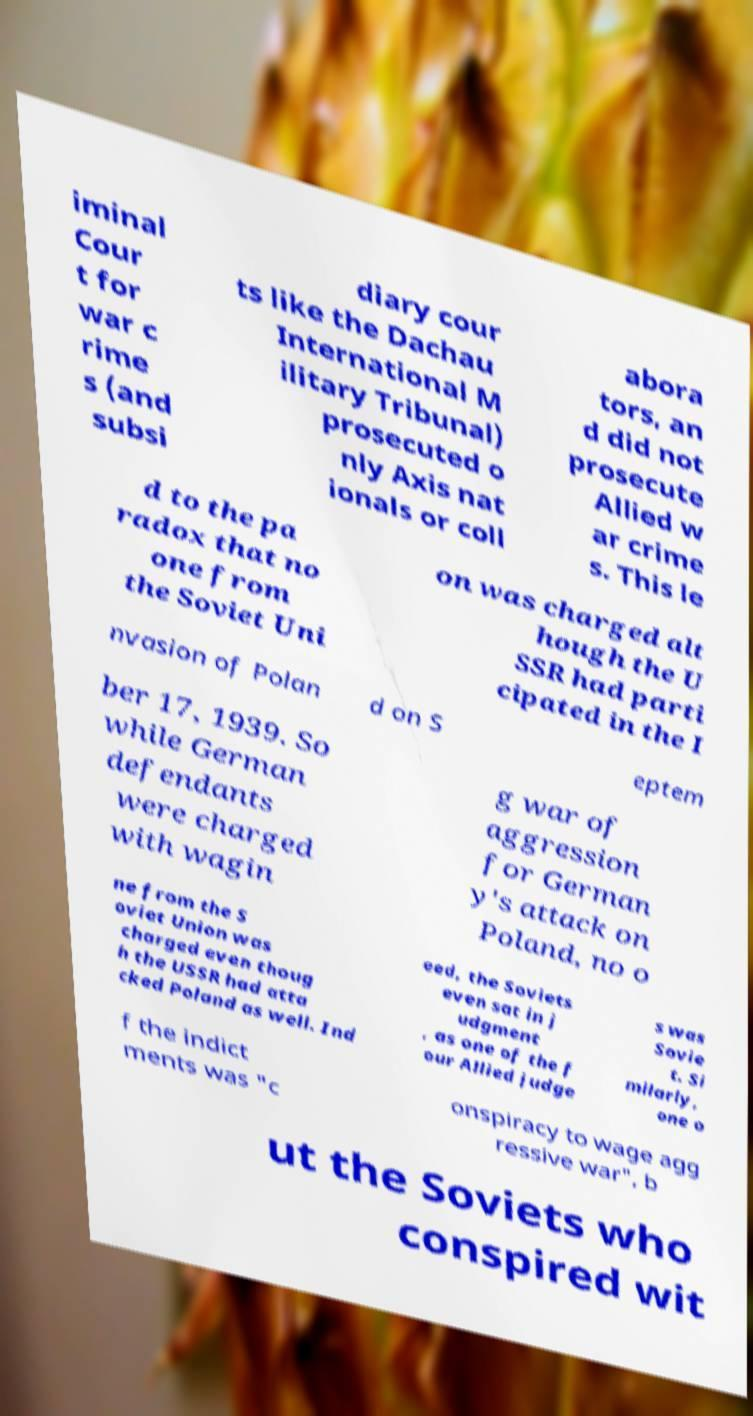What messages or text are displayed in this image? I need them in a readable, typed format. iminal Cour t for war c rime s (and subsi diary cour ts like the Dachau International M ilitary Tribunal) prosecuted o nly Axis nat ionals or coll abora tors, an d did not prosecute Allied w ar crime s. This le d to the pa radox that no one from the Soviet Uni on was charged alt hough the U SSR had parti cipated in the I nvasion of Polan d on S eptem ber 17, 1939. So while German defendants were charged with wagin g war of aggression for German y's attack on Poland, no o ne from the S oviet Union was charged even thoug h the USSR had atta cked Poland as well. Ind eed, the Soviets even sat in j udgment , as one of the f our Allied judge s was Sovie t. Si milarly, one o f the indict ments was "c onspiracy to wage agg ressive war", b ut the Soviets who conspired wit 